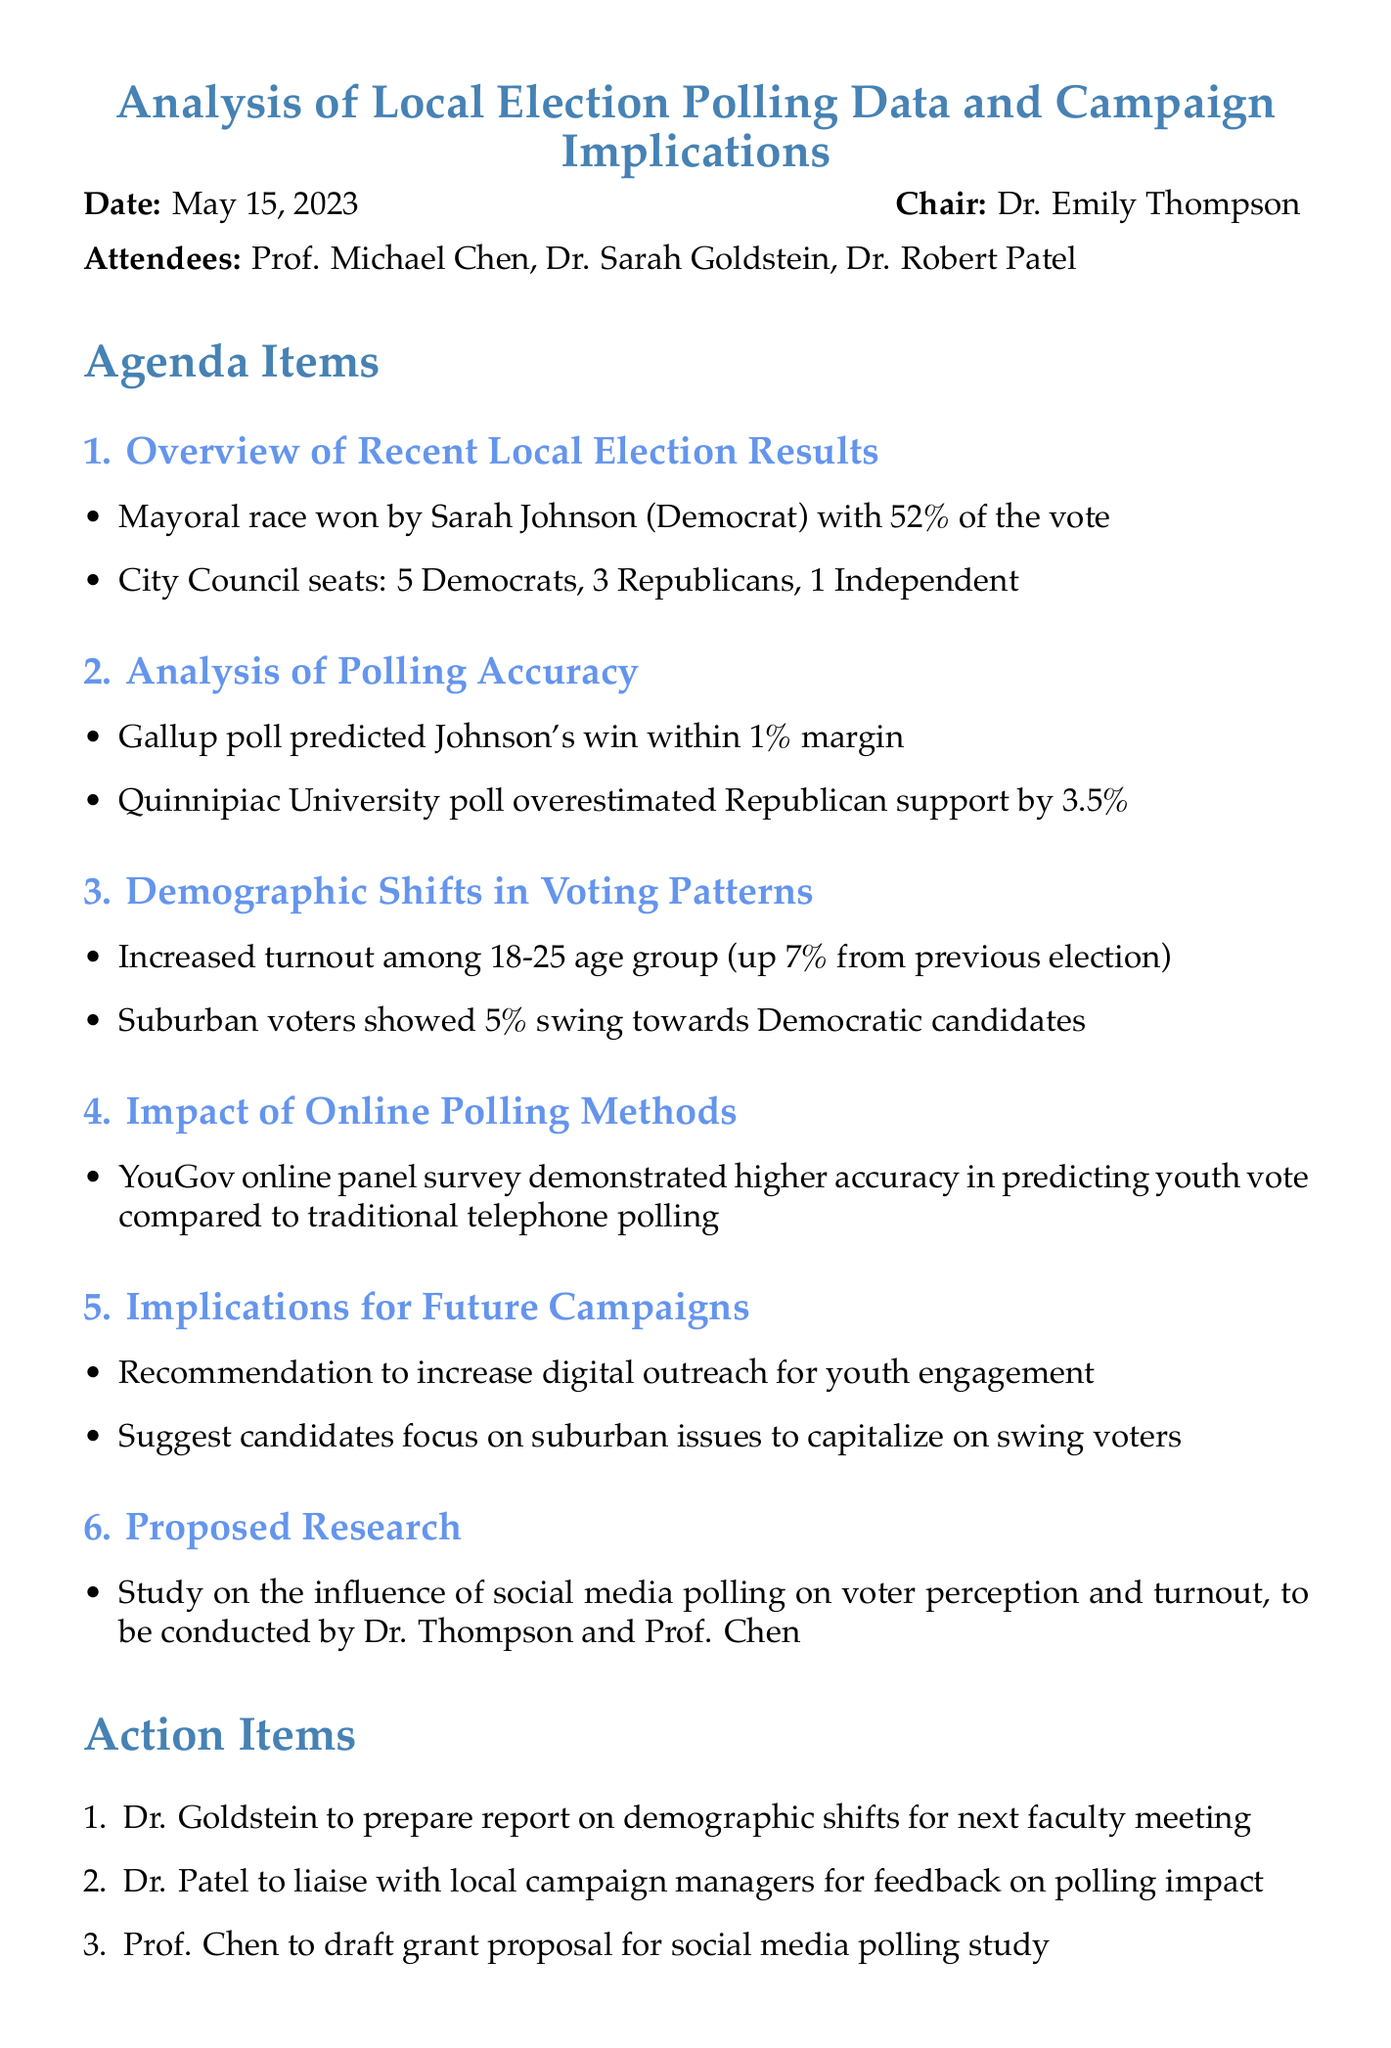What was the date of the meeting? The date of the meeting is explicitly stated at the beginning of the document.
Answer: May 15, 2023 Who won the mayoral race? The winner of the mayoral race is specified in the overview of recent local election results.
Answer: Sarah Johnson What percentage of the vote did Sarah Johnson receive? This information is included in the section about the recent local election results.
Answer: 52% Which polling organization was cited for overestimating Republican support? This question requires recalling details about polling accuracy mentioned in the document.
Answer: Quinnipiac University What demographic showed a 7% increase in turnout? The demographic is outlined within the section on demographic shifts in voting patterns.
Answer: 18-25 age group What method demonstrated higher accuracy in predicting youth votes? The effectiveness of various polling methods is discussed, specifying the method that performed better.
Answer: YouGov online panel survey What are the implications suggested for future campaigns? The document outlines strategic recommendations based on analysis, specifically indicating suggestions for candidate focus.
Answer: Increase digital outreach for youth engagement Who is responsible for preparing a report on demographic shifts? This task is listed as an action item in the document, involving a specific attendee.
Answer: Dr. Goldstein 